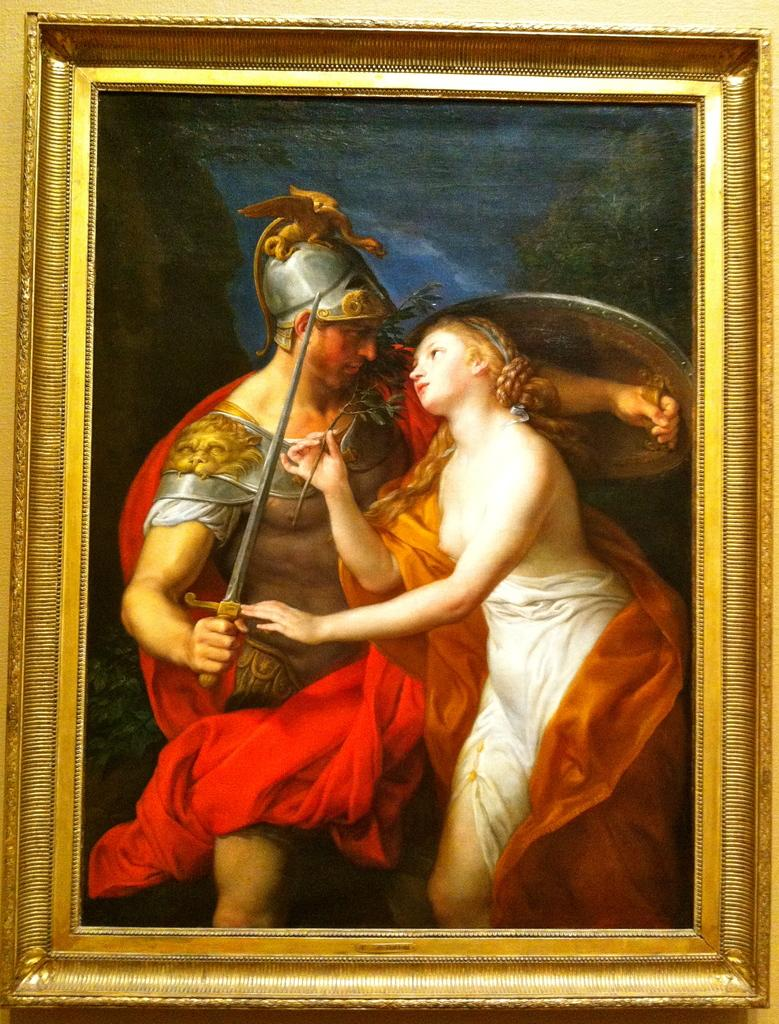What can be seen in the image? There is a frame in the image. Is there a boat in the frame in the image? There is no mention of a boat in the provided facts, so we cannot determine if there is one in the frame. 